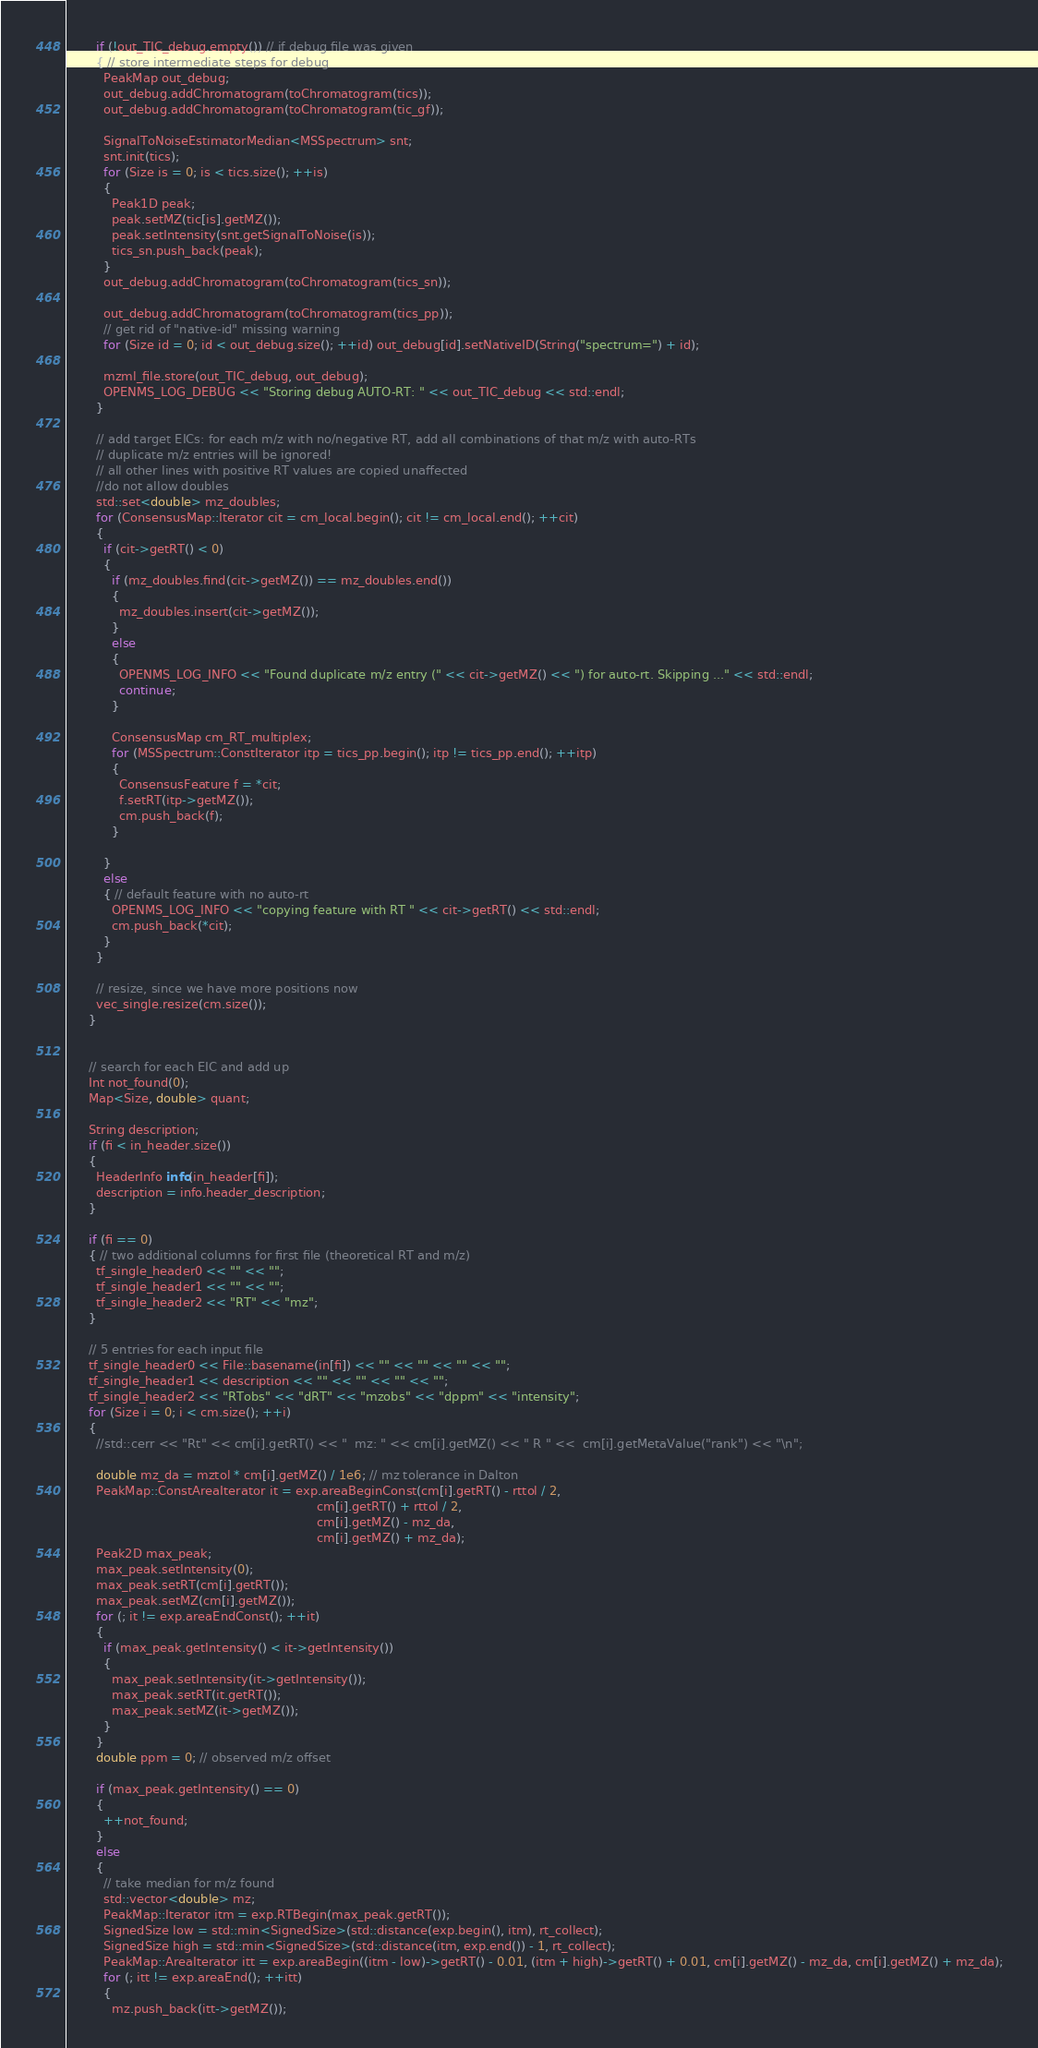<code> <loc_0><loc_0><loc_500><loc_500><_C++_>
        if (!out_TIC_debug.empty()) // if debug file was given
        { // store intermediate steps for debug
          PeakMap out_debug;
          out_debug.addChromatogram(toChromatogram(tics));
          out_debug.addChromatogram(toChromatogram(tic_gf));

          SignalToNoiseEstimatorMedian<MSSpectrum> snt;
          snt.init(tics);
          for (Size is = 0; is < tics.size(); ++is)
          {
            Peak1D peak;
            peak.setMZ(tic[is].getMZ());
            peak.setIntensity(snt.getSignalToNoise(is));
            tics_sn.push_back(peak);
          }
          out_debug.addChromatogram(toChromatogram(tics_sn));

          out_debug.addChromatogram(toChromatogram(tics_pp));
          // get rid of "native-id" missing warning
          for (Size id = 0; id < out_debug.size(); ++id) out_debug[id].setNativeID(String("spectrum=") + id);

          mzml_file.store(out_TIC_debug, out_debug);
          OPENMS_LOG_DEBUG << "Storing debug AUTO-RT: " << out_TIC_debug << std::endl;
        }

        // add target EICs: for each m/z with no/negative RT, add all combinations of that m/z with auto-RTs
        // duplicate m/z entries will be ignored!
        // all other lines with positive RT values are copied unaffected
        //do not allow doubles
        std::set<double> mz_doubles;
        for (ConsensusMap::Iterator cit = cm_local.begin(); cit != cm_local.end(); ++cit)
        {
          if (cit->getRT() < 0)
          {
            if (mz_doubles.find(cit->getMZ()) == mz_doubles.end())
            {
              mz_doubles.insert(cit->getMZ());
            }
            else
            {
              OPENMS_LOG_INFO << "Found duplicate m/z entry (" << cit->getMZ() << ") for auto-rt. Skipping ..." << std::endl;
              continue;
            }

            ConsensusMap cm_RT_multiplex;
            for (MSSpectrum::ConstIterator itp = tics_pp.begin(); itp != tics_pp.end(); ++itp)
            {
              ConsensusFeature f = *cit;
              f.setRT(itp->getMZ());
              cm.push_back(f);
            }

          }
          else
          { // default feature with no auto-rt
            OPENMS_LOG_INFO << "copying feature with RT " << cit->getRT() << std::endl;
            cm.push_back(*cit);
          }
        }

        // resize, since we have more positions now
        vec_single.resize(cm.size());
      }


      // search for each EIC and add up
      Int not_found(0);
      Map<Size, double> quant;

      String description;
      if (fi < in_header.size())
      {
        HeaderInfo info(in_header[fi]);
        description = info.header_description;
      }

      if (fi == 0)
      { // two additional columns for first file (theoretical RT and m/z)
        tf_single_header0 << "" << "";
        tf_single_header1 << "" << "";
        tf_single_header2 << "RT" << "mz";
      }

      // 5 entries for each input file
      tf_single_header0 << File::basename(in[fi]) << "" << "" << "" << "";
      tf_single_header1 << description << "" << "" << "" << "";
      tf_single_header2 << "RTobs" << "dRT" << "mzobs" << "dppm" << "intensity";
      for (Size i = 0; i < cm.size(); ++i)
      {
        //std::cerr << "Rt" << cm[i].getRT() << "  mz: " << cm[i].getMZ() << " R " <<  cm[i].getMetaValue("rank") << "\n";

        double mz_da = mztol * cm[i].getMZ() / 1e6; // mz tolerance in Dalton
        PeakMap::ConstAreaIterator it = exp.areaBeginConst(cm[i].getRT() - rttol / 2,
                                                                  cm[i].getRT() + rttol / 2,
                                                                  cm[i].getMZ() - mz_da,
                                                                  cm[i].getMZ() + mz_da);
        Peak2D max_peak;
        max_peak.setIntensity(0);
        max_peak.setRT(cm[i].getRT());
        max_peak.setMZ(cm[i].getMZ());
        for (; it != exp.areaEndConst(); ++it)
        {
          if (max_peak.getIntensity() < it->getIntensity())
          {
            max_peak.setIntensity(it->getIntensity());
            max_peak.setRT(it.getRT());
            max_peak.setMZ(it->getMZ());
          }
        }
        double ppm = 0; // observed m/z offset

        if (max_peak.getIntensity() == 0)
        {
          ++not_found;
        }
        else
        {
          // take median for m/z found
          std::vector<double> mz;
          PeakMap::Iterator itm = exp.RTBegin(max_peak.getRT());
          SignedSize low = std::min<SignedSize>(std::distance(exp.begin(), itm), rt_collect);
          SignedSize high = std::min<SignedSize>(std::distance(itm, exp.end()) - 1, rt_collect);
          PeakMap::AreaIterator itt = exp.areaBegin((itm - low)->getRT() - 0.01, (itm + high)->getRT() + 0.01, cm[i].getMZ() - mz_da, cm[i].getMZ() + mz_da);
          for (; itt != exp.areaEnd(); ++itt)
          {
            mz.push_back(itt->getMZ());</code> 